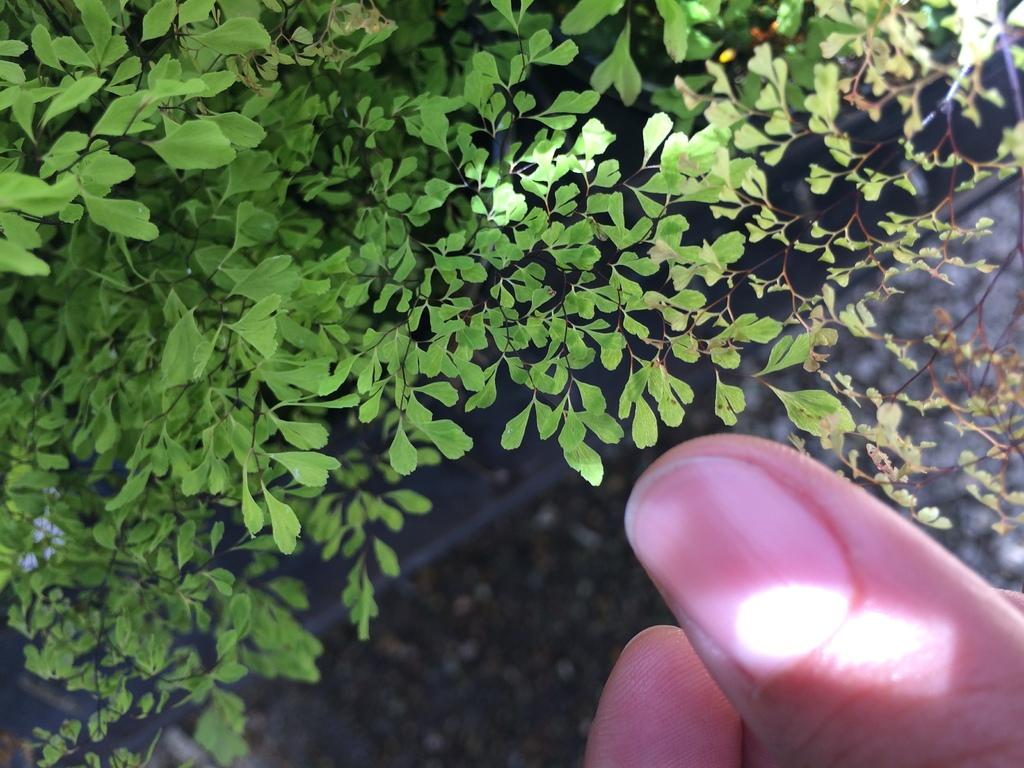What can be seen at the bottom of the image? There is a person's hand and a walkway at the bottom of the image. What is located on the left side of the image? There are plants on the left side of the image. What type of zephyr is being carried on the tray in the image? There is no tray or zephyr present in the image. What reward is the person holding in their hand in the image? There is no reward being held in the person's hand in the image. 